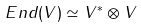Convert formula to latex. <formula><loc_0><loc_0><loc_500><loc_500>E n d ( V ) \simeq V ^ { * } \otimes V</formula> 